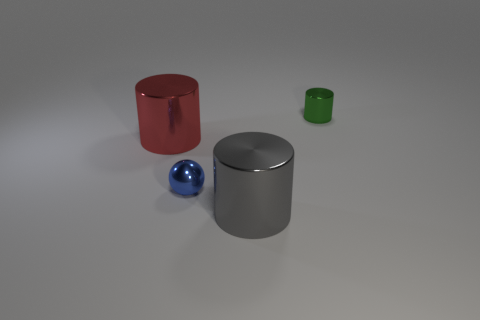What could these objects represent if this was a surrealist art piece? In a surrealist art context, the objects could symbolize a variety of concepts. The red cylinder might represent industry, the silver one could stand for modern technology, the small blue sphere might symbolize individuality in a standardized world, and the tiny green cylinder could signify nature's resilience. 